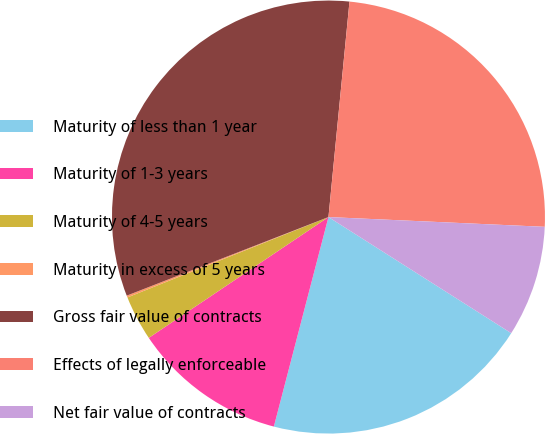Convert chart. <chart><loc_0><loc_0><loc_500><loc_500><pie_chart><fcel>Maturity of less than 1 year<fcel>Maturity of 1-3 years<fcel>Maturity of 4-5 years<fcel>Maturity in excess of 5 years<fcel>Gross fair value of contracts<fcel>Effects of legally enforceable<fcel>Net fair value of contracts<nl><fcel>20.05%<fcel>11.52%<fcel>3.37%<fcel>0.14%<fcel>32.46%<fcel>24.17%<fcel>8.29%<nl></chart> 